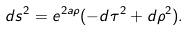<formula> <loc_0><loc_0><loc_500><loc_500>d s ^ { 2 } = e ^ { 2 a \rho } ( - d \tau ^ { 2 } + d \rho ^ { 2 } ) .</formula> 